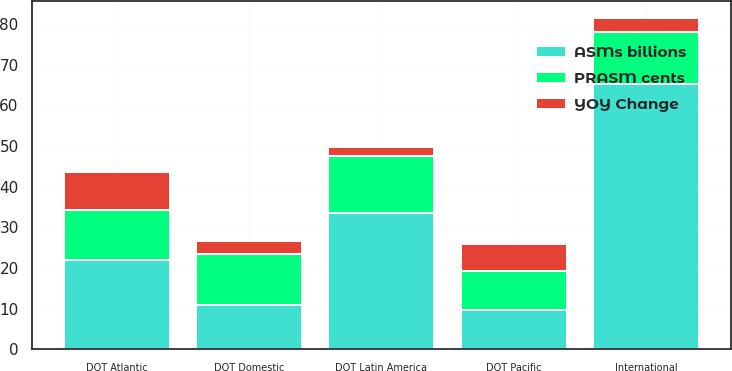Convert chart to OTSL. <chart><loc_0><loc_0><loc_500><loc_500><stacked_bar_chart><ecel><fcel>DOT Domestic<fcel>International<fcel>DOT Latin America<fcel>DOT Atlantic<fcel>DOT Pacific<nl><fcel>PRASM cents<fcel>12.55<fcel>12.86<fcel>14.16<fcel>12.23<fcel>9.76<nl><fcel>YOY Change<fcel>3.1<fcel>3.5<fcel>2<fcel>9.4<fcel>6.6<nl><fcel>ASMs billions<fcel>10.995<fcel>65.2<fcel>33.5<fcel>22.1<fcel>9.6<nl></chart> 